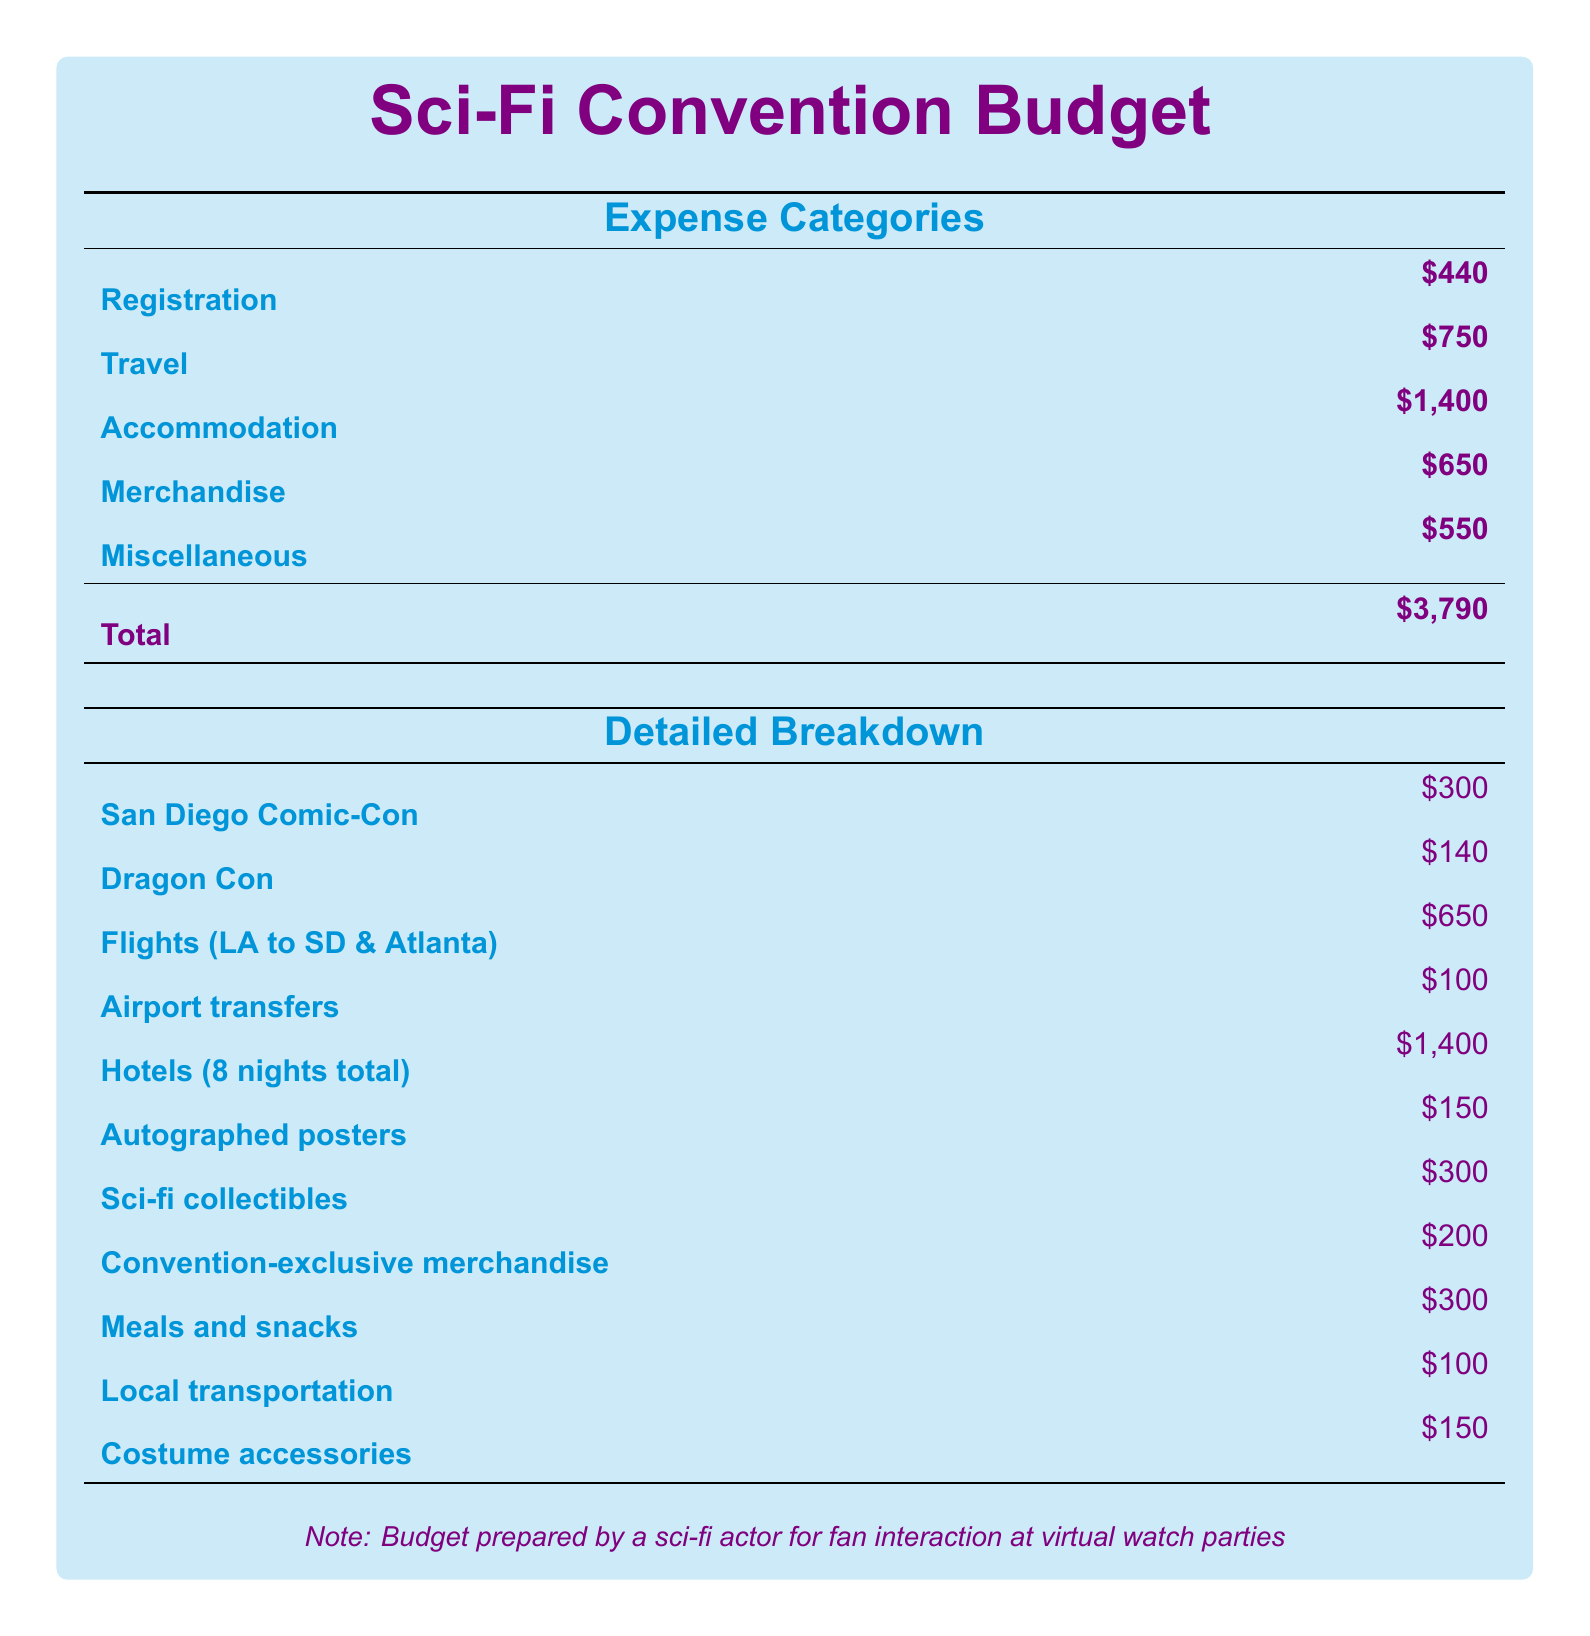What is the total budget for attending the conventions? The total budget is the final amount listed in the document, which adds up all the expenses.
Answer: $3,790 How much is allocated for accommodation? The accommodation cost is specified in the budget table, which provides a clear figure for that category.
Answer: $1,400 What is the expense for travel? The travel expense is explicitly stated within the budget as part of the overall cost breakdown.
Answer: $750 How many nights of hotels are included in the budget? The hotel nights are mentioned under the detailed breakdown section and provide important context for the accommodation costs.
Answer: 8 nights What is the cost for merchandise? The merchandise cost is specifically listed in the expense categories, contributing to the total budget.
Answer: $650 How much is allocated for meals and snacks? The meals and snacks expense appears in the detailed breakdown, outlining the specific costs for this item.
Answer: $300 What type of merchandise has a cost of $200? This cost refers to convention-exclusive merchandise, which is included in the detailed breakdown of expenses.
Answer: Convention-exclusive merchandise Which convention has a registration fee of $300? The San Diego Comic-Con registration fee is clearly outlined in the expense categories table.
Answer: San Diego Comic-Con What is the total cost for flights? The flight costs are detailed as part of the travel expenses, summing up to the total specified.
Answer: $650 